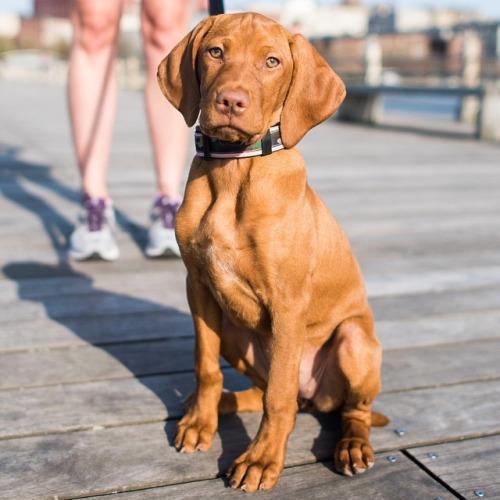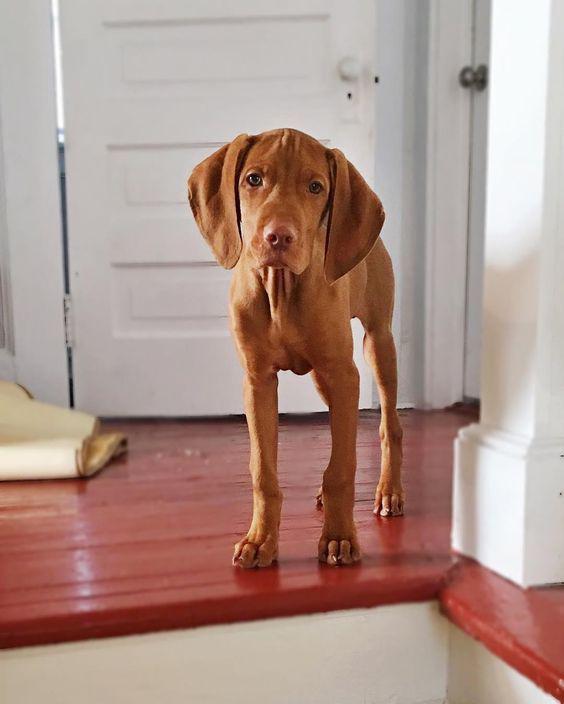The first image is the image on the left, the second image is the image on the right. Given the left and right images, does the statement "The dog in the image on the left is sitting on a wooden surface." hold true? Answer yes or no. Yes. The first image is the image on the left, the second image is the image on the right. For the images shown, is this caption "Each image contains one red-orange dog, which has its face turned forward." true? Answer yes or no. Yes. 